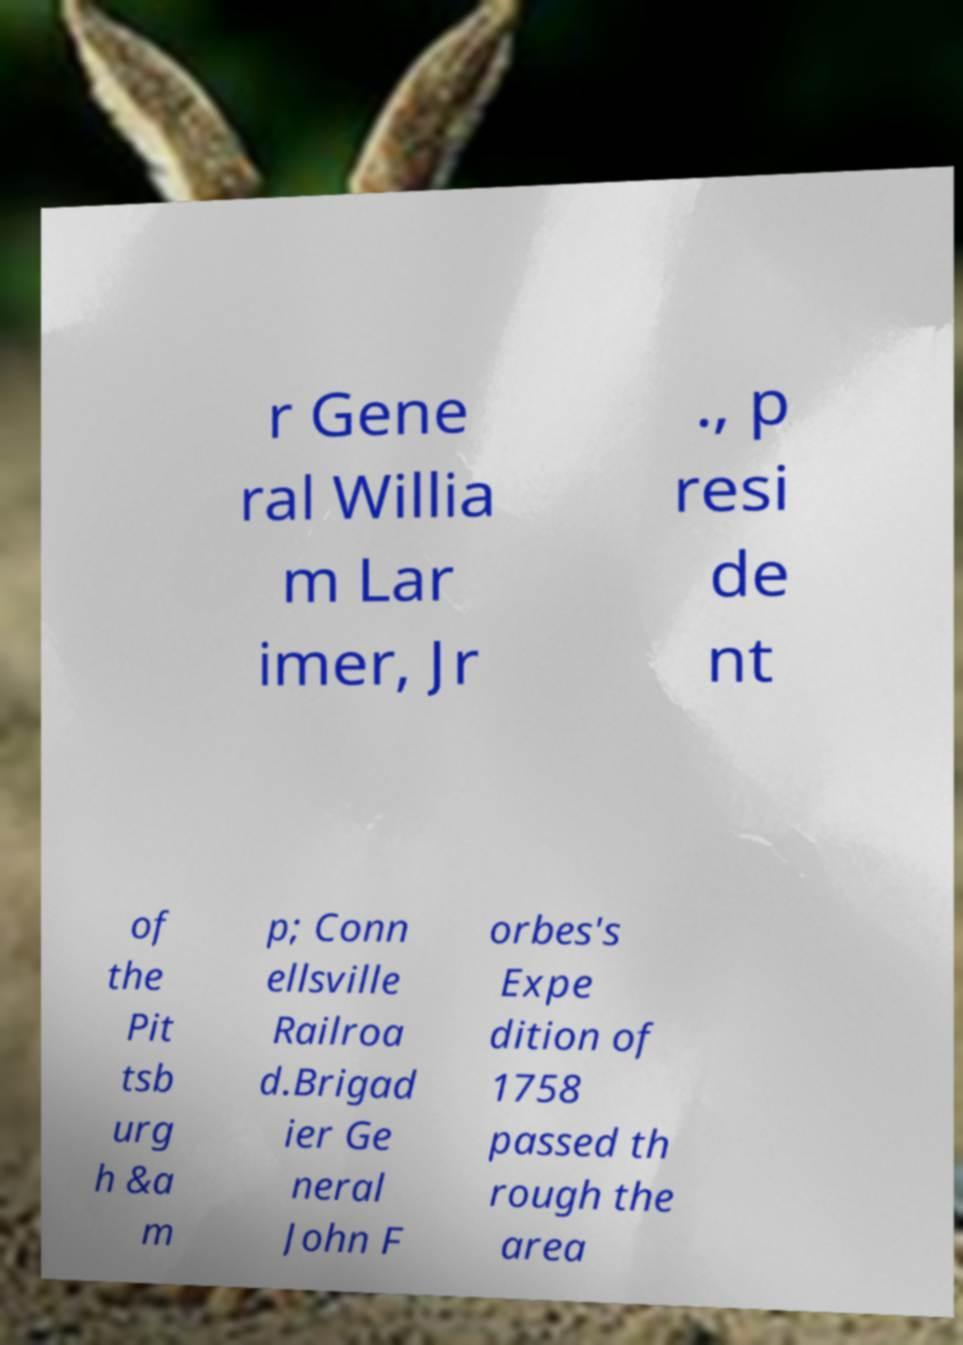Could you extract and type out the text from this image? r Gene ral Willia m Lar imer, Jr ., p resi de nt of the Pit tsb urg h &a m p; Conn ellsville Railroa d.Brigad ier Ge neral John F orbes's Expe dition of 1758 passed th rough the area 